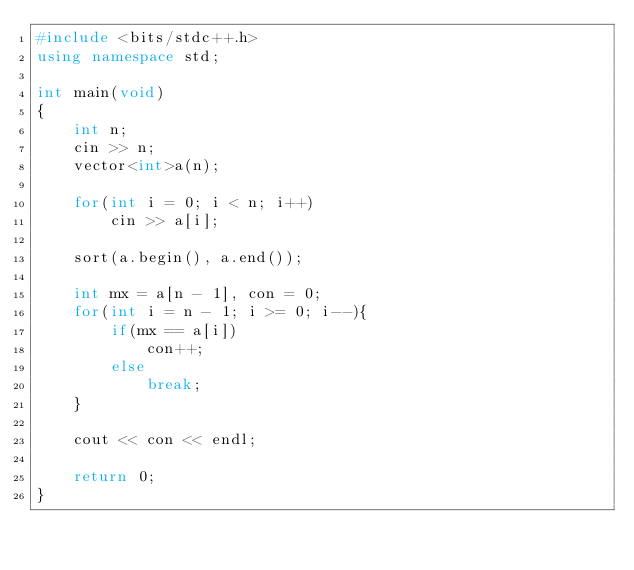Convert code to text. <code><loc_0><loc_0><loc_500><loc_500><_C++_>#include <bits/stdc++.h>
using namespace std;

int main(void)
{
    int n;
    cin >> n;
    vector<int>a(n);

    for(int i = 0; i < n; i++)
        cin >> a[i];

    sort(a.begin(), a.end());

    int mx = a[n - 1], con = 0;
    for(int i = n - 1; i >= 0; i--){
        if(mx == a[i])
            con++;
        else
            break;
    }

    cout << con << endl;

    return 0;
}
</code> 